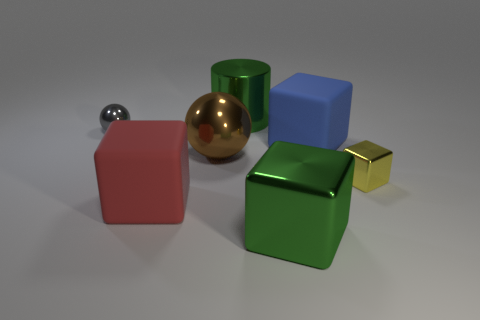Subtract 1 cubes. How many cubes are left? 3 Subtract all gray cubes. Subtract all purple balls. How many cubes are left? 4 Add 1 big blue metallic objects. How many objects exist? 8 Subtract all balls. How many objects are left? 5 Subtract 1 red blocks. How many objects are left? 6 Subtract all big brown shiny spheres. Subtract all blocks. How many objects are left? 2 Add 7 big blue matte things. How many big blue matte things are left? 8 Add 3 large purple rubber cylinders. How many large purple rubber cylinders exist? 3 